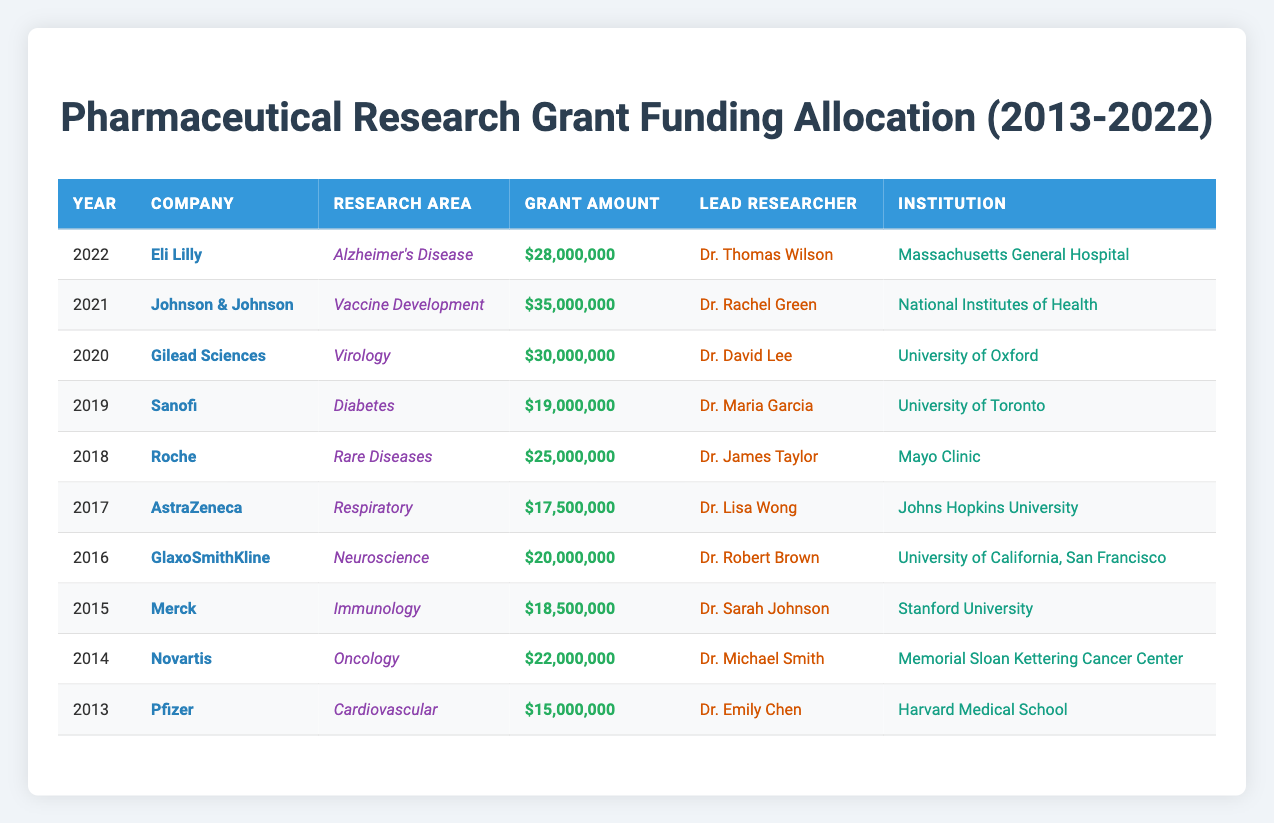What was the highest grant amount awarded in 2021? The table shows that in 2021, Johnson & Johnson received a grant amount of $35,000,000, which is the highest among the listed years.
Answer: $35,000,000 Which company allocated the least amount in 2013? Pfizer allocated a grant amount of $15,000,000 in 2013, which is the only value listed for that year, hence it's the least.
Answer: $15,000,000 What is the total amount of grants awarded over the years 2018 to 2022? Adding the grant amounts from 2018 to 2022: 25,000,000 + 19,000,000 + 30,000,000 + 35,000,000 + 28,000,000 = 137,000,000.
Answer: $137,000,000 Did Eli Lilly receive a grant for oncology research? No, the data indicates that Eli Lilly received a grant for Alzheimer's Disease, not oncology.
Answer: No What year saw the most diverse range of research areas in grants? Analyzing the research areas, 2016 had Neuroscience, 2017 had Respiratory, 2018 had Rare Diseases, 2019 had Diabetes, 2020 had Virology, 2021 had Vaccine Development, and 2022 had Alzheimer’s Disease. Each year from 2016 to 2022 had different research areas, showing diversity.
Answer: 2016 to 2022 What is the average grant amount awarded per year for the years 2015 to 2019? To find the average, first sum the amounts: 18,500,000 + 19,000,000 + 25,000,000 + 30,000,000 + 35,000,000 = 127,500,000. Then divide by 5 (the number of years): 127,500,000 / 5 = 25,500,000.
Answer: $25,500,000 Which research area received the highest single grant amount? Among the entries, Vaccine Development in 2021 received the highest grant amount of $35,000,000, making it the highest single grant across all research areas.
Answer: Vaccine Development Was the total grant amount for cardiovascular research over the decade higher than that for diabetes research? Summing the grants: Cardiovascular (15,000,000) and Diabetes (19,000,000). The total for cardiovascular (15,000,000) is lower than for diabetes (19,000,000), so the statement is false.
Answer: No 